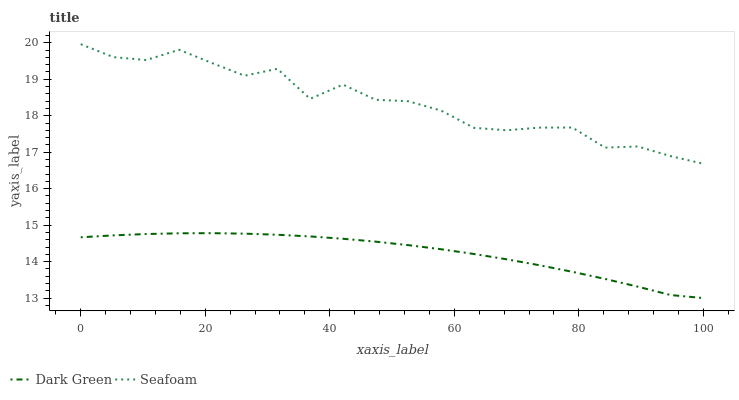Does Dark Green have the minimum area under the curve?
Answer yes or no. Yes. Does Seafoam have the maximum area under the curve?
Answer yes or no. Yes. Does Dark Green have the maximum area under the curve?
Answer yes or no. No. Is Dark Green the smoothest?
Answer yes or no. Yes. Is Seafoam the roughest?
Answer yes or no. Yes. Is Dark Green the roughest?
Answer yes or no. No. Does Seafoam have the highest value?
Answer yes or no. Yes. Does Dark Green have the highest value?
Answer yes or no. No. Is Dark Green less than Seafoam?
Answer yes or no. Yes. Is Seafoam greater than Dark Green?
Answer yes or no. Yes. Does Dark Green intersect Seafoam?
Answer yes or no. No. 